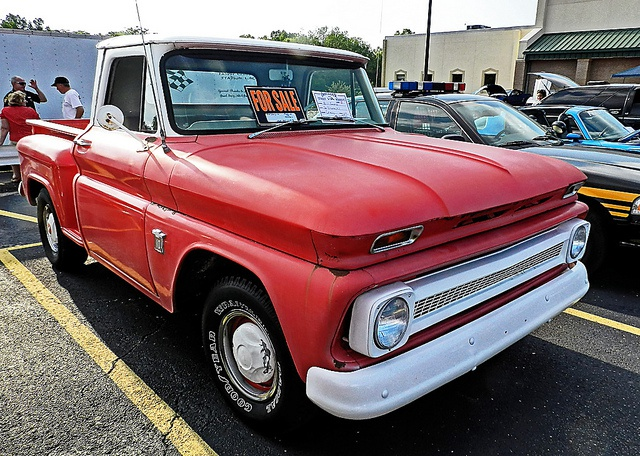Describe the objects in this image and their specific colors. I can see truck in white, black, brown, salmon, and lightgray tones, car in white, black, darkgray, lightgray, and gray tones, car in white, black, lightblue, gray, and lightgray tones, car in white, black, gray, lightgray, and darkgray tones, and people in white, maroon, brown, black, and gray tones in this image. 